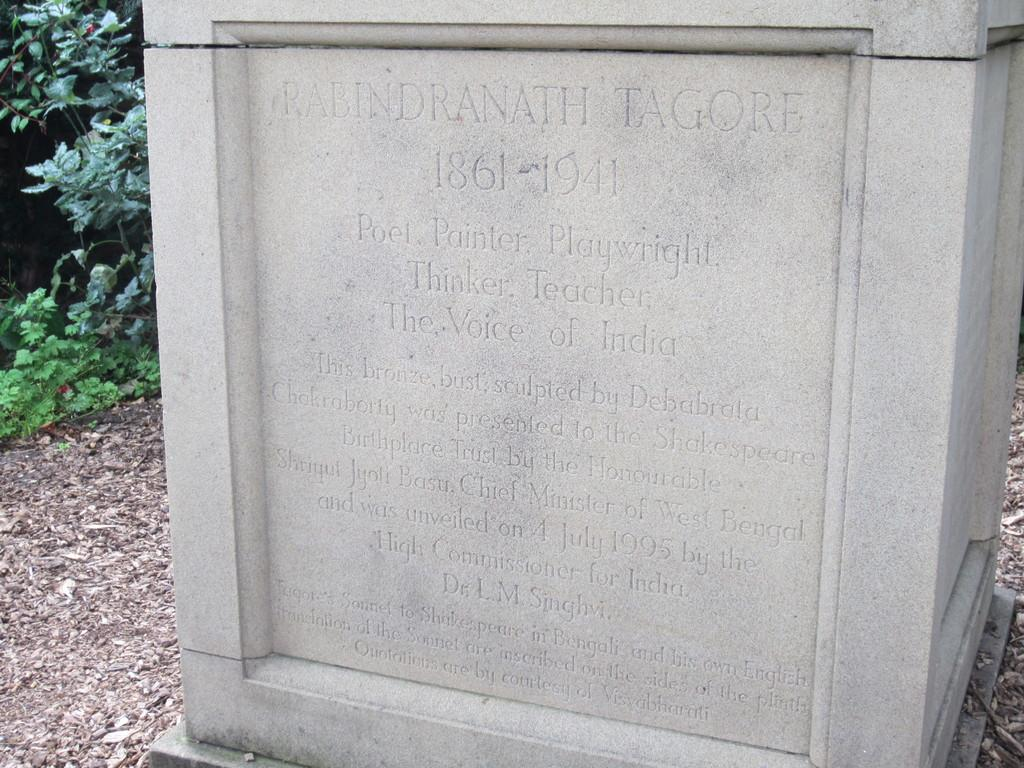What is the main object in the image? There is a memorial stone in the image. What can be seen behind the memorial stone? There are plants behind the memorial stone. What type of ice is being used to write on the memorial stone in the image? There is no ice present in the image, and therefore no ice is being used to write on the memorial stone. 